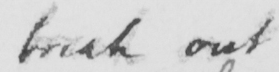Please provide the text content of this handwritten line. break out 